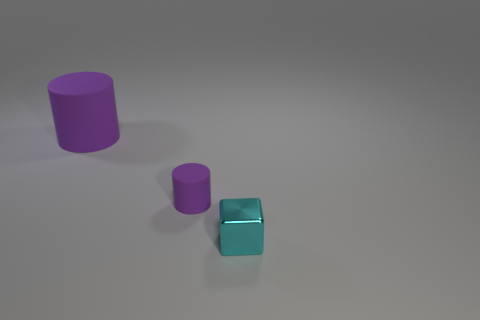Add 1 cyan metallic objects. How many objects exist? 4 Subtract all cylinders. How many objects are left? 1 Subtract all blocks. Subtract all purple matte objects. How many objects are left? 0 Add 3 tiny things. How many tiny things are left? 5 Add 2 purple spheres. How many purple spheres exist? 2 Subtract 0 yellow cubes. How many objects are left? 3 